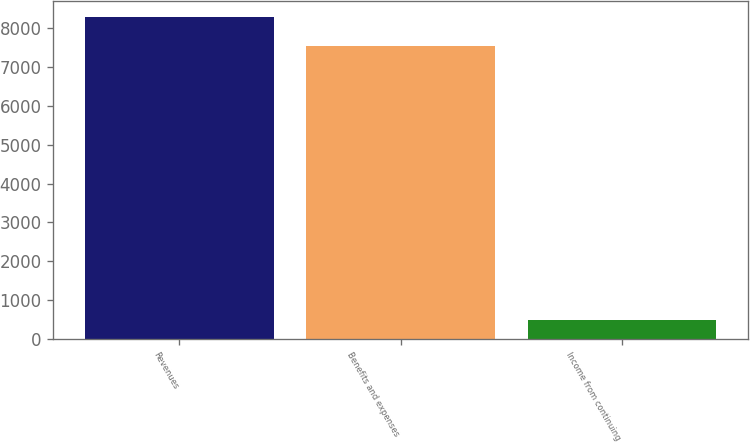<chart> <loc_0><loc_0><loc_500><loc_500><bar_chart><fcel>Revenues<fcel>Benefits and expenses<fcel>Income from continuing<nl><fcel>8298.4<fcel>7544<fcel>482<nl></chart> 